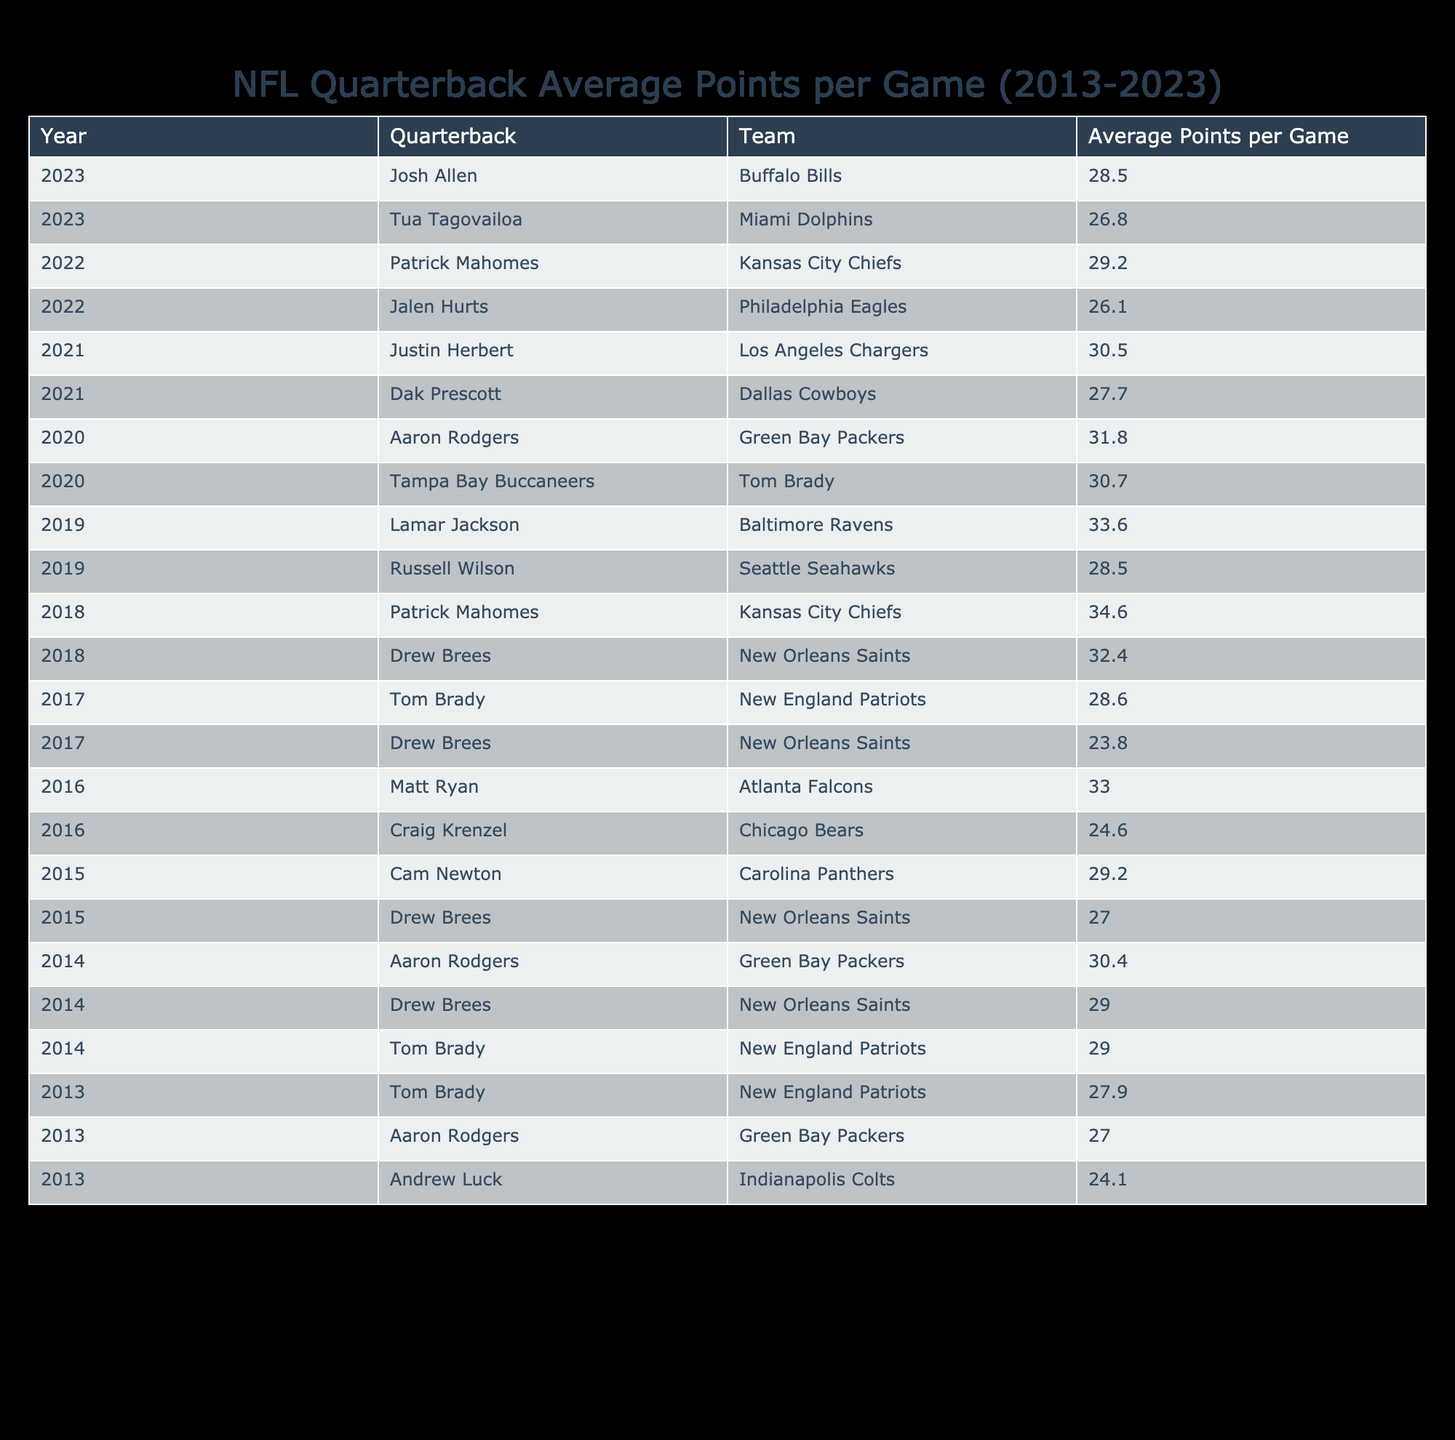What was the highest average points per game recorded by a quarterback from 2013 to 2023? By examining the table, I can see each year's quarterback and their corresponding average points per game. The highest value in the "Average Points per Game" column is 34.6, which belongs to Patrick Mahomes in 2018.
Answer: 34.6 Which quarterback had the lowest average points per game in 2016? Looking at the 2016 row of the table, I find two quarterbacks: Craig Krenzel with an average of 24.6 points and Matt Ryan with 33.0 points. The lowest average belongs to Craig Krenzel at 24.6.
Answer: Craig Krenzel What is the average points per game for Tom Brady over the years he played from 2013 to 2023? Tom Brady's average points per game are 27.9 (2013), 29.0 (2014), 28.6 (2017), 30.7 (2020). To find the average: (27.9 + 29.0 + 28.6 + 30.7) / 4 = 29.15.
Answer: 29.15 Did any quarterback achieve an average points per game above 30 in the year 2021? Looking through the table specifically for the year 2021, I see Dak Prescott with 27.7 and Justin Herbert with 30.5. Only Justin Herbert exceeded 30 points per game, making the answer yes.
Answer: Yes Which quarterback had the highest average points per game in 2020, and what was it? Checking the 2020 section, Tom Brady scored 30.7 and Aaron Rodgers scored 31.8. The highest was Aaron Rodgers at 31.8 points per game.
Answer: Aaron Rodgers, 31.8 What was the total average points per game for Drew Brees throughout his appearances in the table? The table shows Drew Brees with averages of 29.0 (2014), 27.0 (2015), 23.8 (2017), and 32.4 (2018). Adding these together gives: 29.0 + 27.0 + 23.8 + 32.4 = 112.2. Dividing by the number of appearances (4) yields an average of 28.05 points per game.
Answer: 28.05 How many quarterbacks had an average points per game lower than 25 in the data provided? In the table, I see Craig Krenzel with an average of 24.6 points in 2016. No other quarterbacks have an average less than 25 when observed across the years listed. Thus, Craig Krenzel is the only one, so the answer is one.
Answer: 1 Which years featured an average points per game above 30, and how many quarterbacks achieved this? Reviewing the table, I see 2014 (Aaron Rodgers 30.4 and Drew Brees 29.0), 2018 (Patrick Mahomes 34.6 and Drew Brees 32.4), and 2020 (Aaron Rodgers 31.8). The only years with averages above 30 are 2014, 2018, and 2020, with a total of 4 quarterbacks in this range.
Answer: 2014, 2018, 2020; 4 quarterbacks 